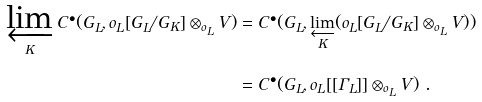Convert formula to latex. <formula><loc_0><loc_0><loc_500><loc_500>\varprojlim _ { K } C ^ { \bullet } ( G _ { L } , o _ { L } [ G _ { L } / G _ { K } ] \otimes _ { o _ { L } } V ) & = C ^ { \bullet } ( G _ { L } , \varprojlim _ { K } ( o _ { L } [ G _ { L } / G _ { K } ] \otimes _ { o _ { L } } V ) ) \\ & = C ^ { \bullet } ( G _ { L } , o _ { L } [ [ \Gamma _ { L } ] ] \otimes _ { o _ { L } } V ) \ .</formula> 